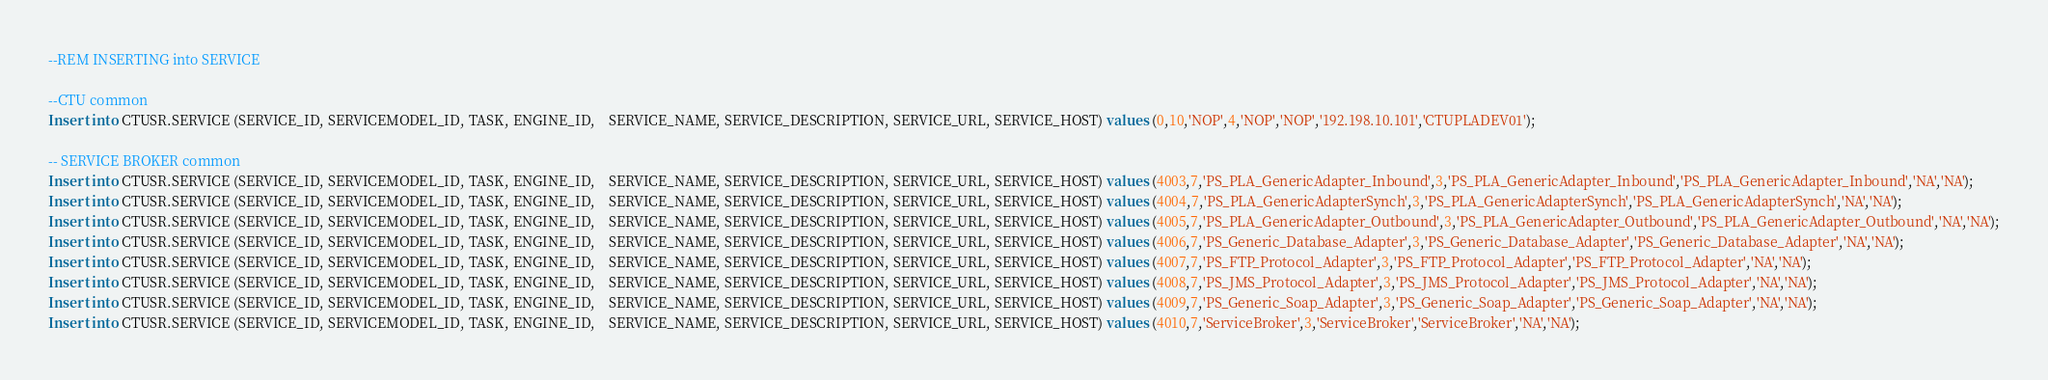Convert code to text. <code><loc_0><loc_0><loc_500><loc_500><_SQL_>--REM INSERTING into SERVICE

--CTU common
Insert into CTUSR.SERVICE (SERVICE_ID, SERVICEMODEL_ID, TASK, ENGINE_ID,    SERVICE_NAME, SERVICE_DESCRIPTION, SERVICE_URL, SERVICE_HOST) values (0,10,'NOP',4,'NOP','NOP','192.198.10.101','CTUPLADEV01');

-- SERVICE BROKER common
Insert into CTUSR.SERVICE (SERVICE_ID, SERVICEMODEL_ID, TASK, ENGINE_ID,    SERVICE_NAME, SERVICE_DESCRIPTION, SERVICE_URL, SERVICE_HOST) values (4003,7,'PS_PLA_GenericAdapter_Inbound',3,'PS_PLA_GenericAdapter_Inbound','PS_PLA_GenericAdapter_Inbound','NA','NA');
Insert into CTUSR.SERVICE (SERVICE_ID, SERVICEMODEL_ID, TASK, ENGINE_ID,    SERVICE_NAME, SERVICE_DESCRIPTION, SERVICE_URL, SERVICE_HOST) values (4004,7,'PS_PLA_GenericAdapterSynch',3,'PS_PLA_GenericAdapterSynch','PS_PLA_GenericAdapterSynch','NA','NA');
Insert into CTUSR.SERVICE (SERVICE_ID, SERVICEMODEL_ID, TASK, ENGINE_ID,    SERVICE_NAME, SERVICE_DESCRIPTION, SERVICE_URL, SERVICE_HOST) values (4005,7,'PS_PLA_GenericAdapter_Outbound',3,'PS_PLA_GenericAdapter_Outbound','PS_PLA_GenericAdapter_Outbound','NA','NA');
Insert into CTUSR.SERVICE (SERVICE_ID, SERVICEMODEL_ID, TASK, ENGINE_ID,    SERVICE_NAME, SERVICE_DESCRIPTION, SERVICE_URL, SERVICE_HOST) values (4006,7,'PS_Generic_Database_Adapter',3,'PS_Generic_Database_Adapter','PS_Generic_Database_Adapter','NA','NA');
Insert into CTUSR.SERVICE (SERVICE_ID, SERVICEMODEL_ID, TASK, ENGINE_ID,    SERVICE_NAME, SERVICE_DESCRIPTION, SERVICE_URL, SERVICE_HOST) values (4007,7,'PS_FTP_Protocol_Adapter',3,'PS_FTP_Protocol_Adapter','PS_FTP_Protocol_Adapter','NA','NA');
Insert into CTUSR.SERVICE (SERVICE_ID, SERVICEMODEL_ID, TASK, ENGINE_ID,    SERVICE_NAME, SERVICE_DESCRIPTION, SERVICE_URL, SERVICE_HOST) values (4008,7,'PS_JMS_Protocol_Adapter',3,'PS_JMS_Protocol_Adapter','PS_JMS_Protocol_Adapter','NA','NA');
Insert into CTUSR.SERVICE (SERVICE_ID, SERVICEMODEL_ID, TASK, ENGINE_ID,    SERVICE_NAME, SERVICE_DESCRIPTION, SERVICE_URL, SERVICE_HOST) values (4009,7,'PS_Generic_Soap_Adapter',3,'PS_Generic_Soap_Adapter','PS_Generic_Soap_Adapter','NA','NA');
Insert into CTUSR.SERVICE (SERVICE_ID, SERVICEMODEL_ID, TASK, ENGINE_ID,    SERVICE_NAME, SERVICE_DESCRIPTION, SERVICE_URL, SERVICE_HOST) values (4010,7,'ServiceBroker',3,'ServiceBroker','ServiceBroker','NA','NA');
</code> 